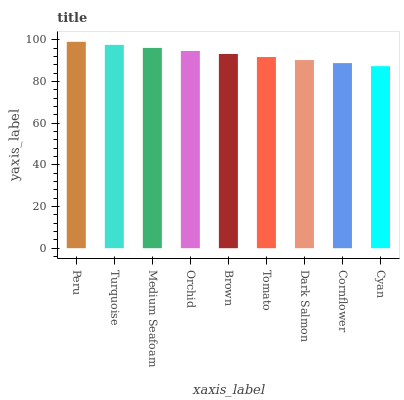Is Cyan the minimum?
Answer yes or no. Yes. Is Peru the maximum?
Answer yes or no. Yes. Is Turquoise the minimum?
Answer yes or no. No. Is Turquoise the maximum?
Answer yes or no. No. Is Peru greater than Turquoise?
Answer yes or no. Yes. Is Turquoise less than Peru?
Answer yes or no. Yes. Is Turquoise greater than Peru?
Answer yes or no. No. Is Peru less than Turquoise?
Answer yes or no. No. Is Brown the high median?
Answer yes or no. Yes. Is Brown the low median?
Answer yes or no. Yes. Is Medium Seafoam the high median?
Answer yes or no. No. Is Cornflower the low median?
Answer yes or no. No. 